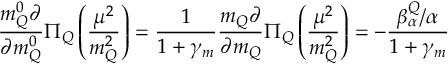Convert formula to latex. <formula><loc_0><loc_0><loc_500><loc_500>\frac { m _ { Q } ^ { 0 } \partial } { \partial m _ { Q } ^ { 0 } } \Pi _ { Q } \left ( \frac { \mu ^ { 2 } } { m _ { Q } ^ { 2 } } \right ) = \frac { 1 } { 1 + \gamma _ { m } } \frac { m _ { Q } \partial } { \partial m _ { Q } } \Pi _ { Q } \left ( \frac { \mu ^ { 2 } } { m _ { Q } ^ { 2 } } \right ) = - \frac { \beta _ { \alpha } ^ { Q } / \alpha } { 1 + \gamma _ { m } }</formula> 